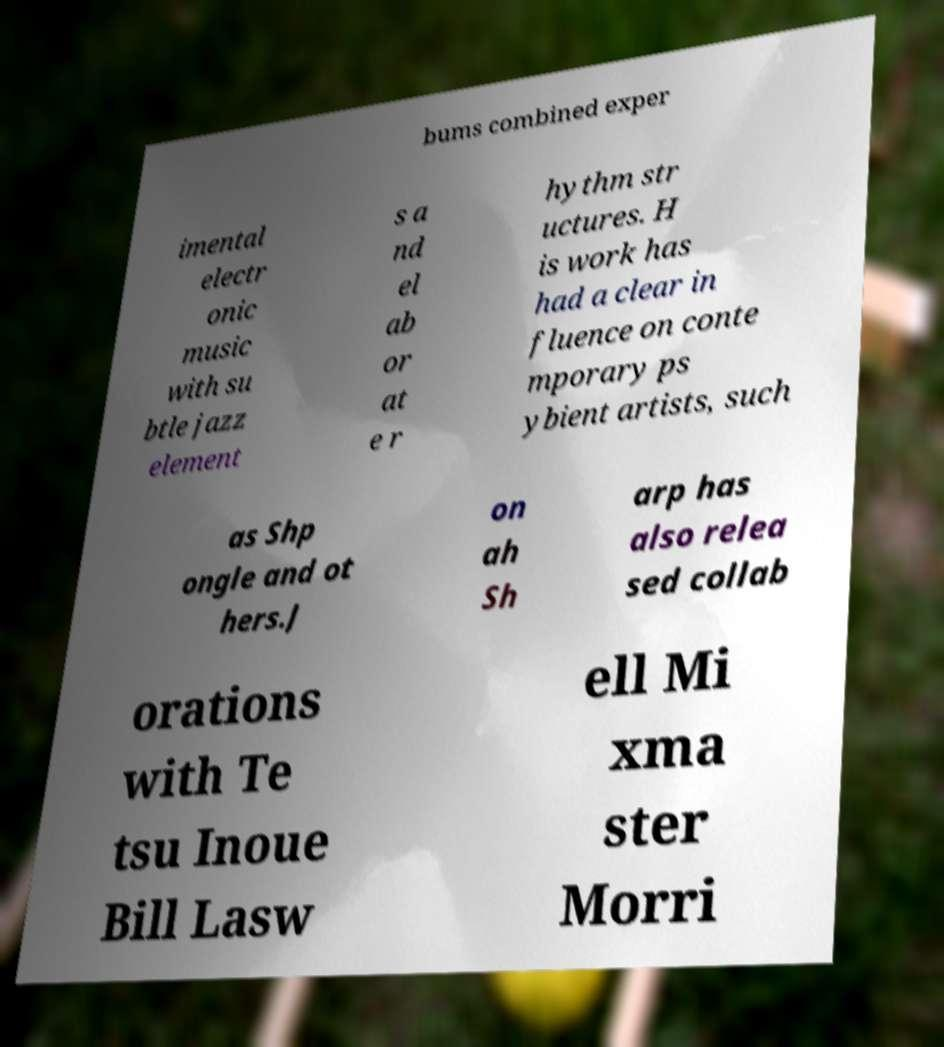Please identify and transcribe the text found in this image. bums combined exper imental electr onic music with su btle jazz element s a nd el ab or at e r hythm str uctures. H is work has had a clear in fluence on conte mporary ps ybient artists, such as Shp ongle and ot hers.J on ah Sh arp has also relea sed collab orations with Te tsu Inoue Bill Lasw ell Mi xma ster Morri 